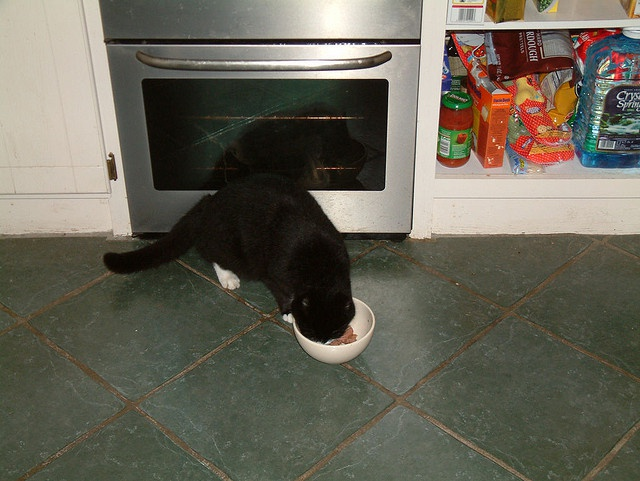Describe the objects in this image and their specific colors. I can see oven in darkgray, black, gray, and ivory tones, cat in darkgray, black, and gray tones, bottle in darkgray, teal, gray, black, and navy tones, bottle in darkgray, maroon, darkgreen, and green tones, and bowl in darkgray, tan, and beige tones in this image. 